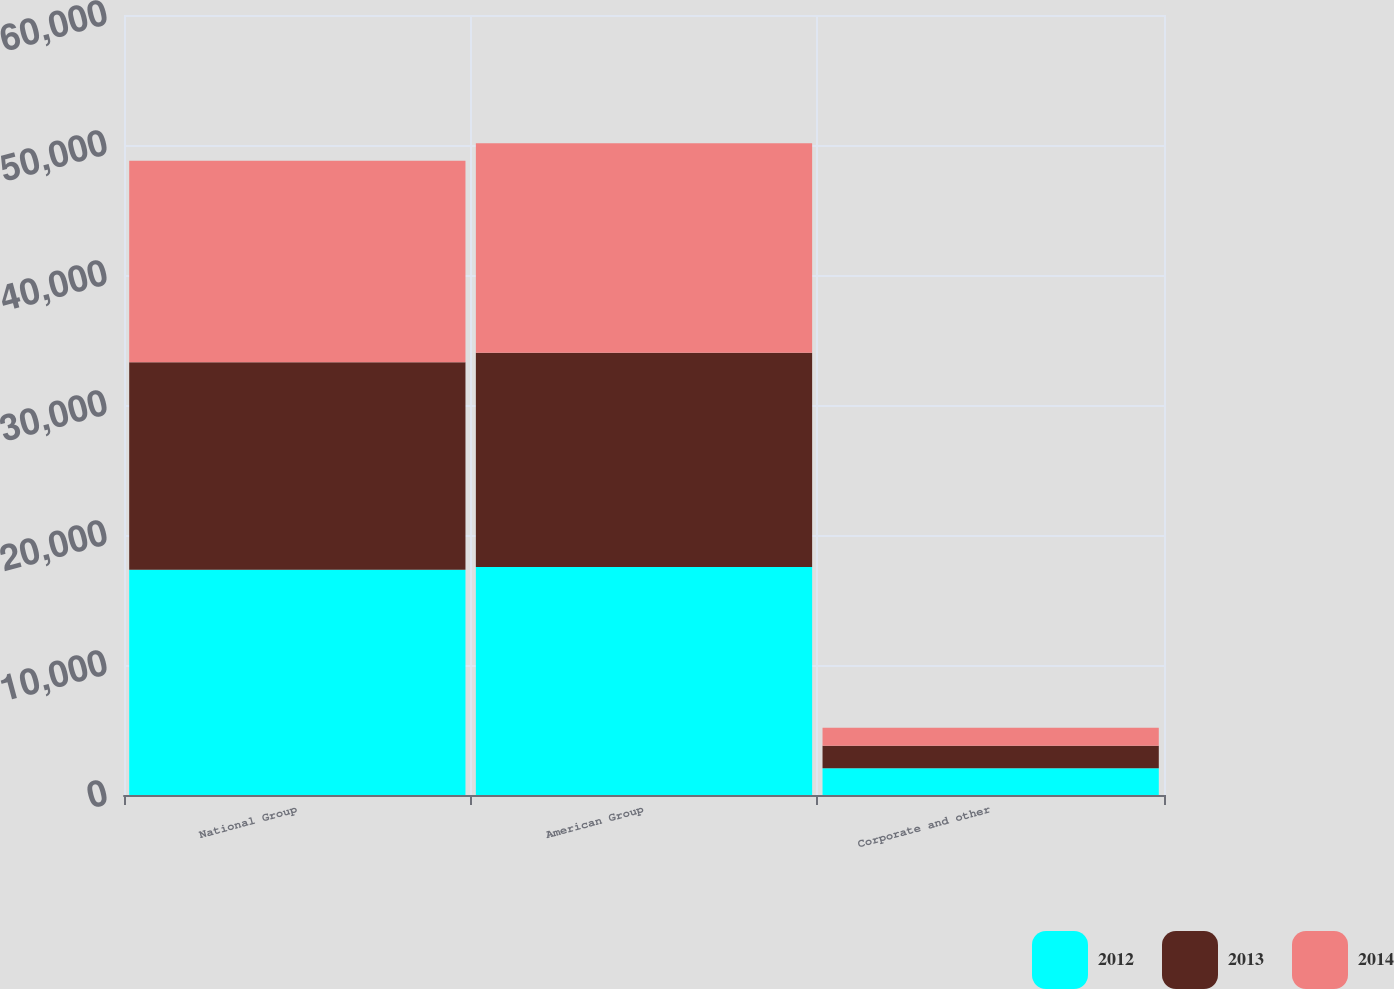Convert chart. <chart><loc_0><loc_0><loc_500><loc_500><stacked_bar_chart><ecel><fcel>National Group<fcel>American Group<fcel>Corporate and other<nl><fcel>2012<fcel>17325<fcel>17532<fcel>2061<nl><fcel>2013<fcel>15968<fcel>16487<fcel>1727<nl><fcel>2014<fcel>15505<fcel>16115<fcel>1393<nl></chart> 